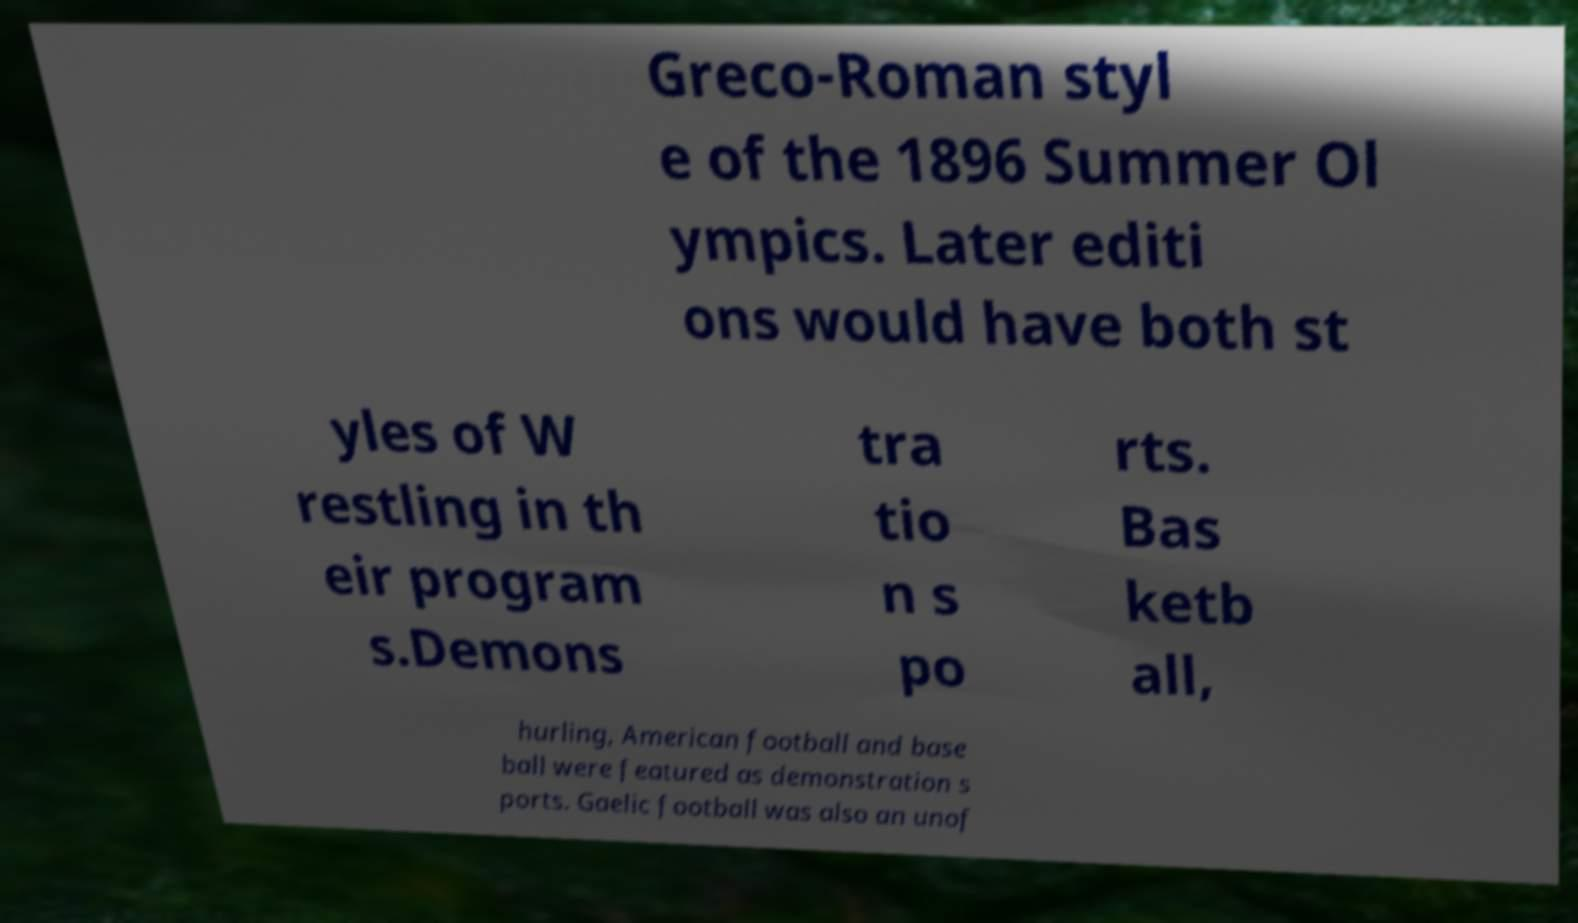Can you accurately transcribe the text from the provided image for me? Greco-Roman styl e of the 1896 Summer Ol ympics. Later editi ons would have both st yles of W restling in th eir program s.Demons tra tio n s po rts. Bas ketb all, hurling, American football and base ball were featured as demonstration s ports. Gaelic football was also an unof 